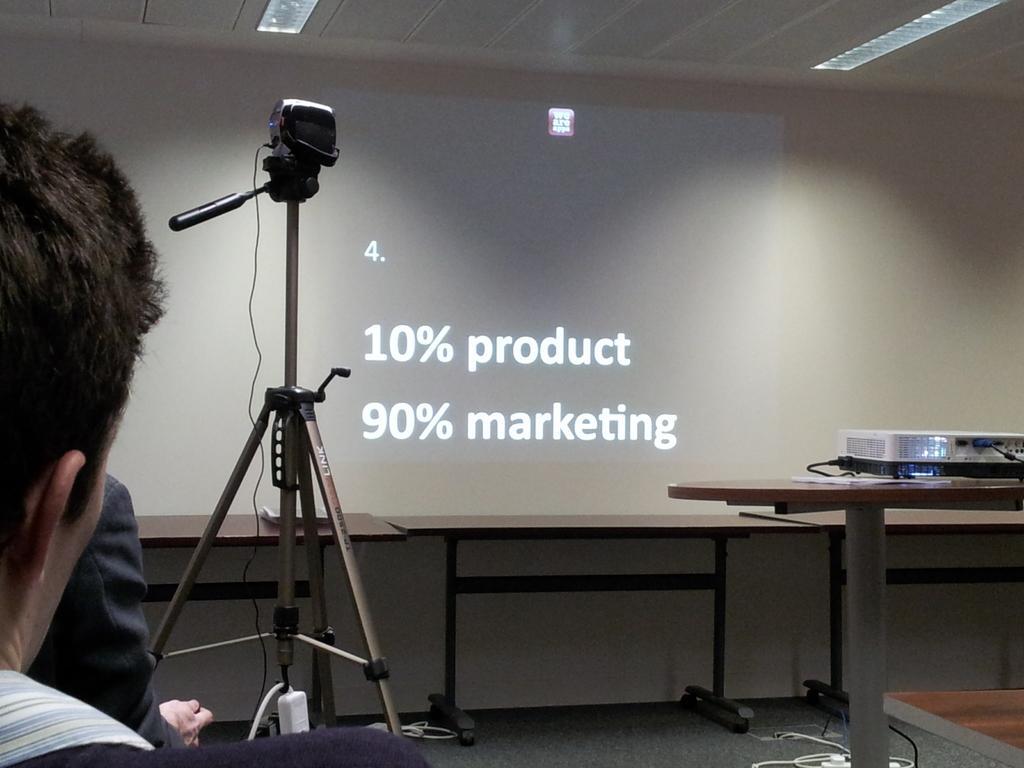Can you describe this image briefly? This picture consists of person on the left side , in the middle I can see a stand , on top of stand I can see a camera and I can see the wall and screen attached to the wall and text visible on screen visible in the middle , in front of wall I can see a table and I can see another table on the right side and there is a machine kept on it. 